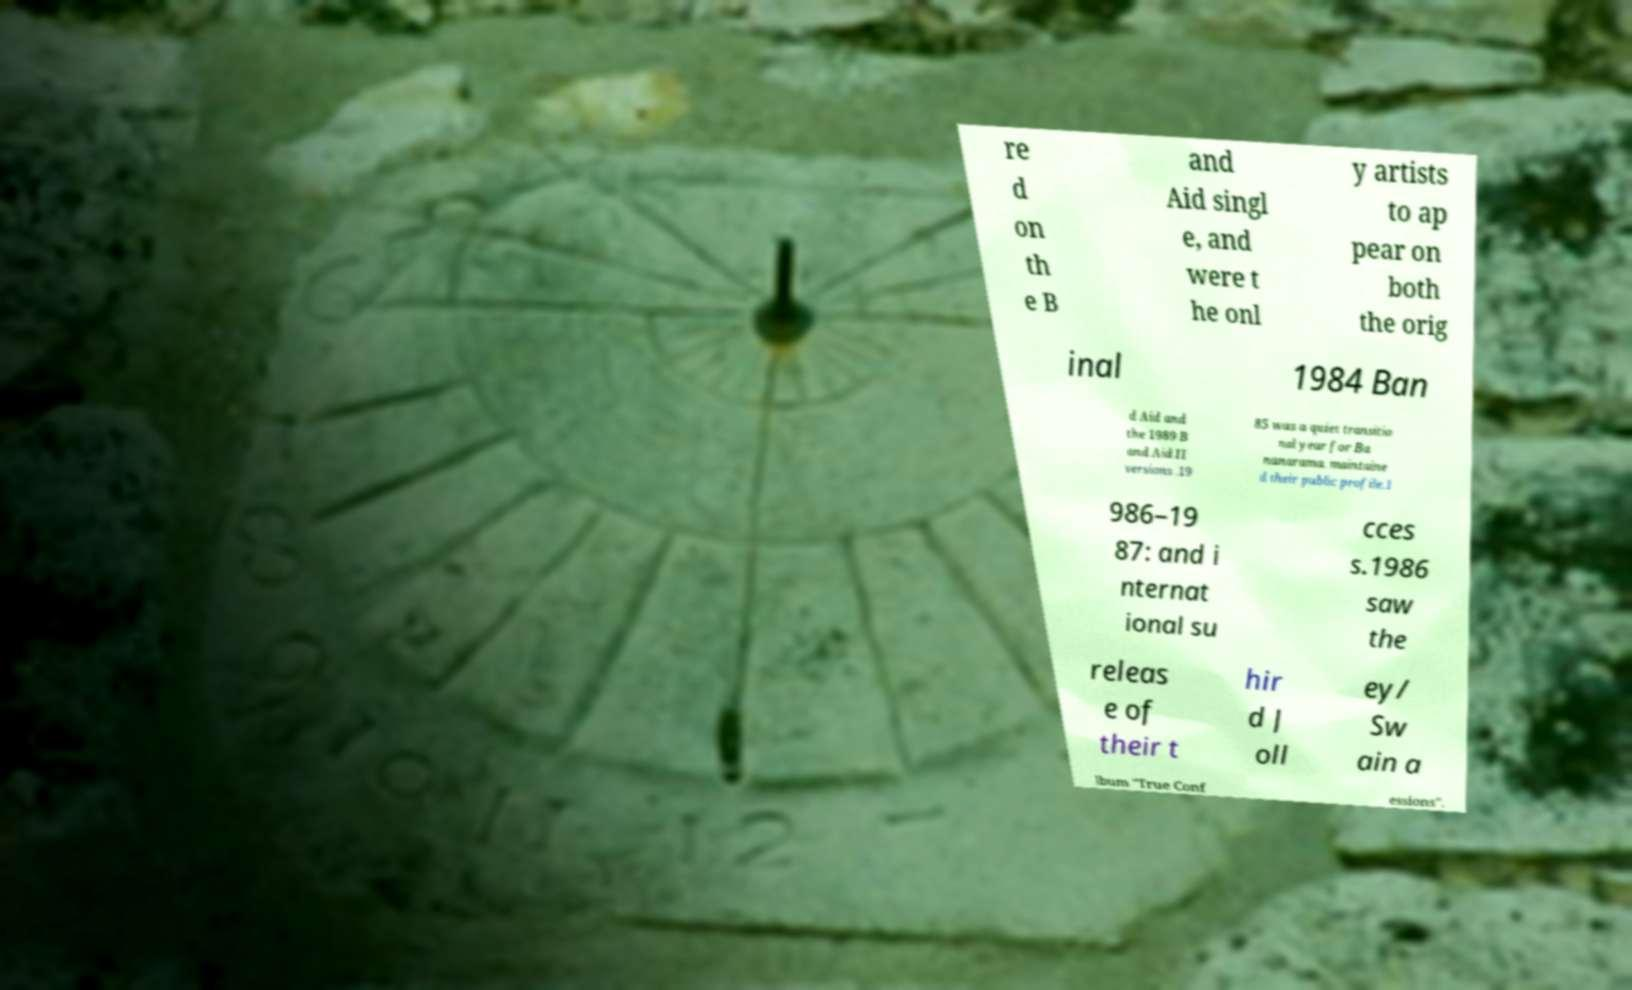Can you read and provide the text displayed in the image?This photo seems to have some interesting text. Can you extract and type it out for me? re d on th e B and Aid singl e, and were t he onl y artists to ap pear on both the orig inal 1984 Ban d Aid and the 1989 B and Aid II versions .19 85 was a quiet transitio nal year for Ba nanarama. maintaine d their public profile.1 986–19 87: and i nternat ional su cces s.1986 saw the releas e of their t hir d J oll ey/ Sw ain a lbum "True Conf essions". 